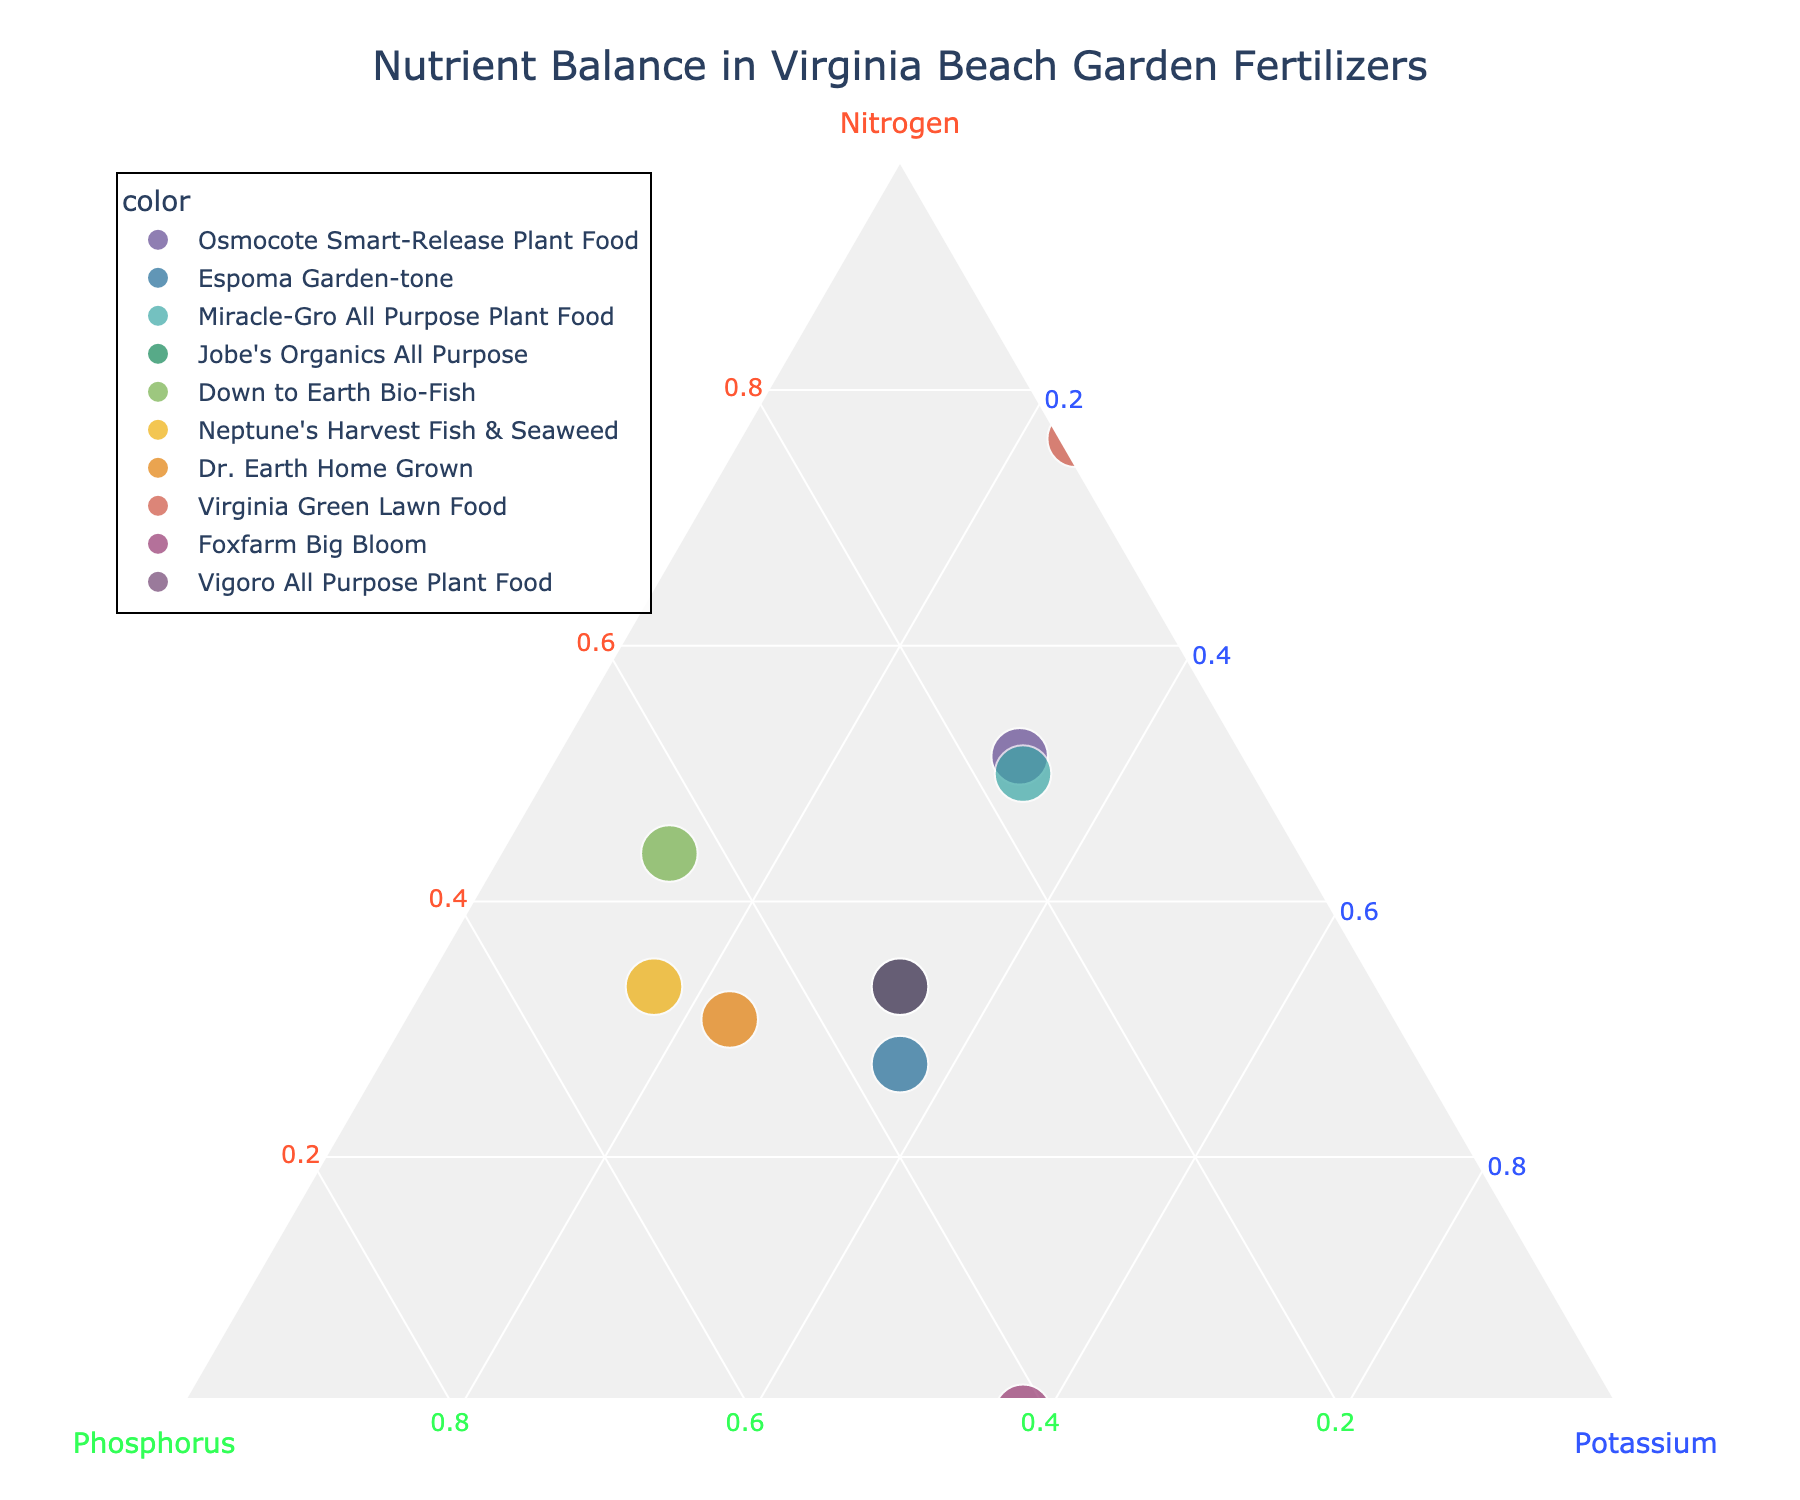What's the title of the figure? The title is usually displayed at the top of the figure. Look for the largest text in the display area.
Answer: Nutrient Balance in Virginia Beach Garden Fertilizers How many fertilizers are plotted in the ternary chart? Each data point represents one fertilizer. Count all of the distinct data points in the chart.
Answer: 10 What color is used to denote the axis for Potassium? The axis titles are color-coded—observe the color next to the label "Potassium".
Answer: Blue Which fertilizer has the highest Nitrogen content? Identify the point that is closest to the Nitrogen axis (A) vertex.
Answer: Virginia Green Lawn Food Is there any fertilizer with equal parts Nitrogen, Phosphorus, and Potassium? Check for data points where all axes show approximately equal values.
Answer: Vigoro All Purpose Plant Food Which fertilizer has the lowest Phosphorus content? Find the data point closest to the Phosphorus axis (B) vertex, then check the hover information for lowest value on Phosphorus.
Answer: Virginia Green Lawn Food How does the composition of Down to Earth Bio-Fish compare to Miracle-Gro All Purpose Plant Food? Evaluate the position of both on the ternary plot and compare their proximity to the Nitrogen, Phosphorus, and Potassium axes.
Answer: Down to Earth Bio-Fish is lower in Nitrogen, higher in Phosphorus, and lower in Potassium Which fertilizer is closest to balanced in nutrients? Look for data points that are nearly equidistant from all three axes.
Answer: Espoma Garden-tone Does Foxfarm Big Bloom have a higher composition of Phosphorus or Potassium? Check the respective ratios on the ternary plot, considering the positions relative to the axes.
Answer: Phosphorus What are the relative compositions of Nitrogen, Phosphorus, and Potassium in Neptune's Harvest Fish & Seaweed fertilizer? Hover over the specific point for this fertilizer and refer to the hover template showing the percentages.
Answer: ~40% Nitrogen, ~50% Phosphorus, ~10% Potassium 